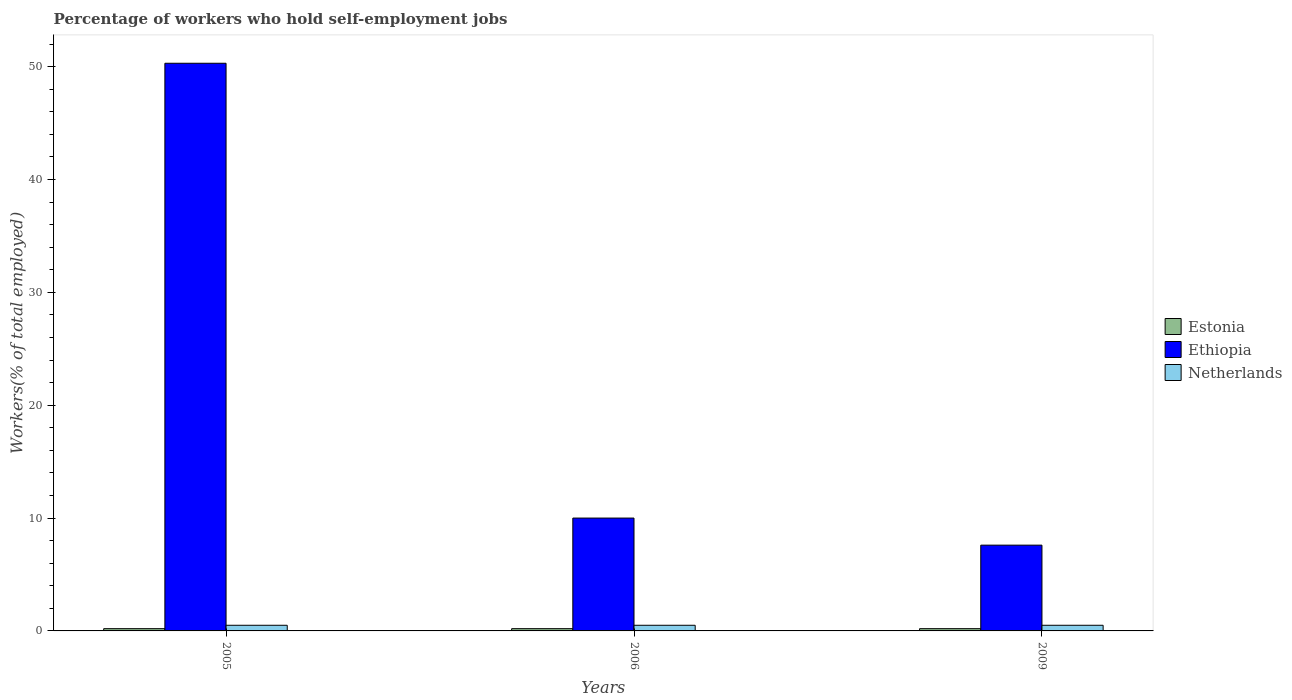How many different coloured bars are there?
Give a very brief answer. 3. Are the number of bars per tick equal to the number of legend labels?
Your response must be concise. Yes. How many bars are there on the 3rd tick from the left?
Provide a short and direct response. 3. How many bars are there on the 3rd tick from the right?
Offer a very short reply. 3. What is the label of the 2nd group of bars from the left?
Provide a succinct answer. 2006. In how many cases, is the number of bars for a given year not equal to the number of legend labels?
Provide a short and direct response. 0. What is the percentage of self-employed workers in Ethiopia in 2009?
Keep it short and to the point. 7.6. Across all years, what is the maximum percentage of self-employed workers in Estonia?
Make the answer very short. 0.2. Across all years, what is the minimum percentage of self-employed workers in Netherlands?
Provide a succinct answer. 0.5. In which year was the percentage of self-employed workers in Netherlands maximum?
Provide a succinct answer. 2005. What is the difference between the percentage of self-employed workers in Estonia in 2005 and that in 2009?
Provide a short and direct response. 0. What is the difference between the percentage of self-employed workers in Ethiopia in 2005 and the percentage of self-employed workers in Estonia in 2009?
Your answer should be very brief. 50.1. What is the average percentage of self-employed workers in Estonia per year?
Ensure brevity in your answer.  0.2. In the year 2009, what is the difference between the percentage of self-employed workers in Estonia and percentage of self-employed workers in Ethiopia?
Ensure brevity in your answer.  -7.4. In how many years, is the percentage of self-employed workers in Estonia greater than 42 %?
Keep it short and to the point. 0. What is the ratio of the percentage of self-employed workers in Netherlands in 2005 to that in 2009?
Give a very brief answer. 1. Is the percentage of self-employed workers in Netherlands in 2005 less than that in 2006?
Provide a short and direct response. No. Is the difference between the percentage of self-employed workers in Estonia in 2005 and 2006 greater than the difference between the percentage of self-employed workers in Ethiopia in 2005 and 2006?
Provide a succinct answer. No. What is the difference between the highest and the lowest percentage of self-employed workers in Ethiopia?
Your answer should be very brief. 42.7. Is the sum of the percentage of self-employed workers in Ethiopia in 2005 and 2006 greater than the maximum percentage of self-employed workers in Netherlands across all years?
Give a very brief answer. Yes. What does the 1st bar from the left in 2009 represents?
Your answer should be very brief. Estonia. Is it the case that in every year, the sum of the percentage of self-employed workers in Netherlands and percentage of self-employed workers in Ethiopia is greater than the percentage of self-employed workers in Estonia?
Keep it short and to the point. Yes. What is the difference between two consecutive major ticks on the Y-axis?
Offer a terse response. 10. Does the graph contain grids?
Make the answer very short. No. How many legend labels are there?
Give a very brief answer. 3. What is the title of the graph?
Your response must be concise. Percentage of workers who hold self-employment jobs. What is the label or title of the Y-axis?
Offer a very short reply. Workers(% of total employed). What is the Workers(% of total employed) in Estonia in 2005?
Keep it short and to the point. 0.2. What is the Workers(% of total employed) of Ethiopia in 2005?
Your answer should be very brief. 50.3. What is the Workers(% of total employed) of Estonia in 2006?
Offer a terse response. 0.2. What is the Workers(% of total employed) in Netherlands in 2006?
Offer a very short reply. 0.5. What is the Workers(% of total employed) of Estonia in 2009?
Give a very brief answer. 0.2. What is the Workers(% of total employed) of Ethiopia in 2009?
Ensure brevity in your answer.  7.6. Across all years, what is the maximum Workers(% of total employed) of Estonia?
Ensure brevity in your answer.  0.2. Across all years, what is the maximum Workers(% of total employed) in Ethiopia?
Ensure brevity in your answer.  50.3. Across all years, what is the maximum Workers(% of total employed) in Netherlands?
Provide a short and direct response. 0.5. Across all years, what is the minimum Workers(% of total employed) in Estonia?
Give a very brief answer. 0.2. Across all years, what is the minimum Workers(% of total employed) of Ethiopia?
Ensure brevity in your answer.  7.6. What is the total Workers(% of total employed) in Estonia in the graph?
Your answer should be compact. 0.6. What is the total Workers(% of total employed) in Ethiopia in the graph?
Offer a terse response. 67.9. What is the difference between the Workers(% of total employed) in Estonia in 2005 and that in 2006?
Make the answer very short. 0. What is the difference between the Workers(% of total employed) of Ethiopia in 2005 and that in 2006?
Offer a very short reply. 40.3. What is the difference between the Workers(% of total employed) in Netherlands in 2005 and that in 2006?
Your response must be concise. 0. What is the difference between the Workers(% of total employed) in Estonia in 2005 and that in 2009?
Ensure brevity in your answer.  0. What is the difference between the Workers(% of total employed) in Ethiopia in 2005 and that in 2009?
Make the answer very short. 42.7. What is the difference between the Workers(% of total employed) of Netherlands in 2005 and that in 2009?
Provide a succinct answer. 0. What is the difference between the Workers(% of total employed) in Netherlands in 2006 and that in 2009?
Ensure brevity in your answer.  0. What is the difference between the Workers(% of total employed) in Estonia in 2005 and the Workers(% of total employed) in Ethiopia in 2006?
Provide a succinct answer. -9.8. What is the difference between the Workers(% of total employed) in Ethiopia in 2005 and the Workers(% of total employed) in Netherlands in 2006?
Your response must be concise. 49.8. What is the difference between the Workers(% of total employed) of Estonia in 2005 and the Workers(% of total employed) of Ethiopia in 2009?
Ensure brevity in your answer.  -7.4. What is the difference between the Workers(% of total employed) in Ethiopia in 2005 and the Workers(% of total employed) in Netherlands in 2009?
Give a very brief answer. 49.8. What is the difference between the Workers(% of total employed) of Estonia in 2006 and the Workers(% of total employed) of Ethiopia in 2009?
Ensure brevity in your answer.  -7.4. What is the difference between the Workers(% of total employed) in Estonia in 2006 and the Workers(% of total employed) in Netherlands in 2009?
Offer a very short reply. -0.3. What is the difference between the Workers(% of total employed) in Ethiopia in 2006 and the Workers(% of total employed) in Netherlands in 2009?
Your answer should be very brief. 9.5. What is the average Workers(% of total employed) in Ethiopia per year?
Keep it short and to the point. 22.63. What is the average Workers(% of total employed) of Netherlands per year?
Make the answer very short. 0.5. In the year 2005, what is the difference between the Workers(% of total employed) in Estonia and Workers(% of total employed) in Ethiopia?
Ensure brevity in your answer.  -50.1. In the year 2005, what is the difference between the Workers(% of total employed) in Estonia and Workers(% of total employed) in Netherlands?
Offer a terse response. -0.3. In the year 2005, what is the difference between the Workers(% of total employed) of Ethiopia and Workers(% of total employed) of Netherlands?
Give a very brief answer. 49.8. In the year 2006, what is the difference between the Workers(% of total employed) of Ethiopia and Workers(% of total employed) of Netherlands?
Offer a very short reply. 9.5. What is the ratio of the Workers(% of total employed) in Ethiopia in 2005 to that in 2006?
Offer a very short reply. 5.03. What is the ratio of the Workers(% of total employed) in Netherlands in 2005 to that in 2006?
Your answer should be very brief. 1. What is the ratio of the Workers(% of total employed) of Estonia in 2005 to that in 2009?
Provide a short and direct response. 1. What is the ratio of the Workers(% of total employed) of Ethiopia in 2005 to that in 2009?
Make the answer very short. 6.62. What is the ratio of the Workers(% of total employed) in Netherlands in 2005 to that in 2009?
Your answer should be compact. 1. What is the ratio of the Workers(% of total employed) of Estonia in 2006 to that in 2009?
Offer a terse response. 1. What is the ratio of the Workers(% of total employed) of Ethiopia in 2006 to that in 2009?
Offer a terse response. 1.32. What is the difference between the highest and the second highest Workers(% of total employed) in Estonia?
Offer a terse response. 0. What is the difference between the highest and the second highest Workers(% of total employed) in Ethiopia?
Give a very brief answer. 40.3. What is the difference between the highest and the lowest Workers(% of total employed) in Ethiopia?
Keep it short and to the point. 42.7. What is the difference between the highest and the lowest Workers(% of total employed) of Netherlands?
Your answer should be very brief. 0. 